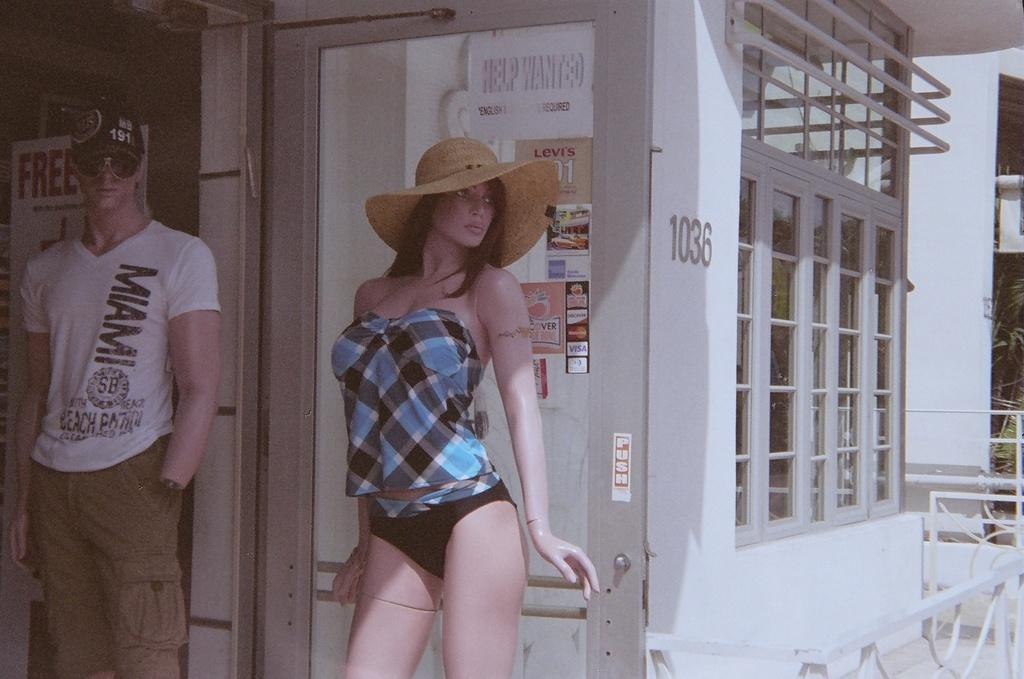How would you summarize this image in a sentence or two? In this image we can see two mannequins and in the background, we can see a building and there is a door with some posters and there is some text on the posters. 